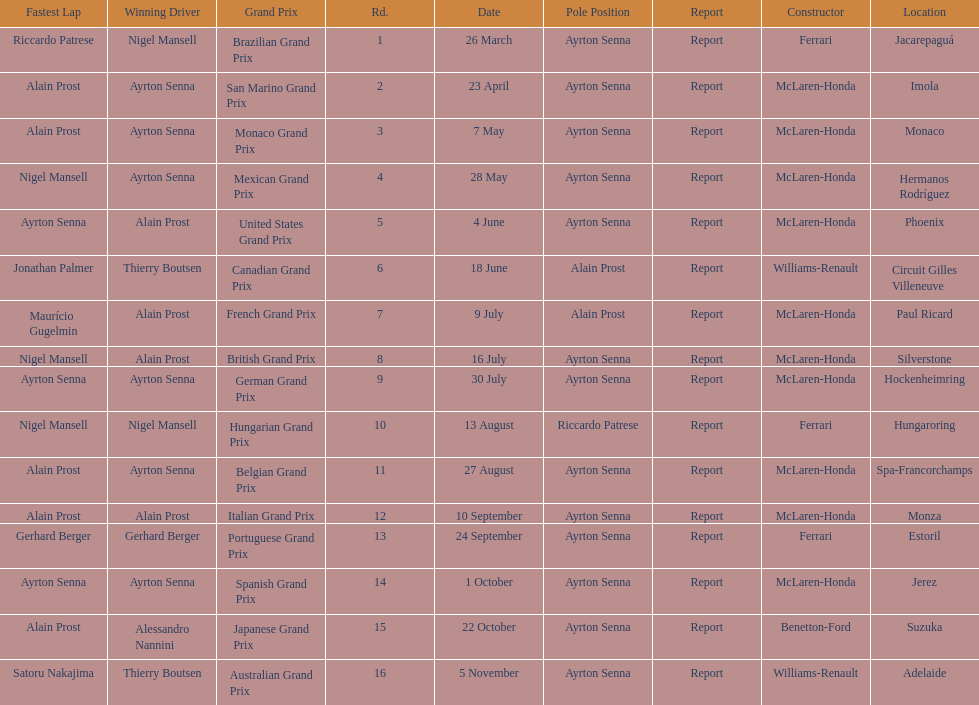Prost won the drivers title, who was his teammate? Ayrton Senna. Can you give me this table as a dict? {'header': ['Fastest Lap', 'Winning Driver', 'Grand Prix', 'Rd.', 'Date', 'Pole Position', 'Report', 'Constructor', 'Location'], 'rows': [['Riccardo Patrese', 'Nigel Mansell', 'Brazilian Grand Prix', '1', '26 March', 'Ayrton Senna', 'Report', 'Ferrari', 'Jacarepaguá'], ['Alain Prost', 'Ayrton Senna', 'San Marino Grand Prix', '2', '23 April', 'Ayrton Senna', 'Report', 'McLaren-Honda', 'Imola'], ['Alain Prost', 'Ayrton Senna', 'Monaco Grand Prix', '3', '7 May', 'Ayrton Senna', 'Report', 'McLaren-Honda', 'Monaco'], ['Nigel Mansell', 'Ayrton Senna', 'Mexican Grand Prix', '4', '28 May', 'Ayrton Senna', 'Report', 'McLaren-Honda', 'Hermanos Rodríguez'], ['Ayrton Senna', 'Alain Prost', 'United States Grand Prix', '5', '4 June', 'Ayrton Senna', 'Report', 'McLaren-Honda', 'Phoenix'], ['Jonathan Palmer', 'Thierry Boutsen', 'Canadian Grand Prix', '6', '18 June', 'Alain Prost', 'Report', 'Williams-Renault', 'Circuit Gilles Villeneuve'], ['Maurício Gugelmin', 'Alain Prost', 'French Grand Prix', '7', '9 July', 'Alain Prost', 'Report', 'McLaren-Honda', 'Paul Ricard'], ['Nigel Mansell', 'Alain Prost', 'British Grand Prix', '8', '16 July', 'Ayrton Senna', 'Report', 'McLaren-Honda', 'Silverstone'], ['Ayrton Senna', 'Ayrton Senna', 'German Grand Prix', '9', '30 July', 'Ayrton Senna', 'Report', 'McLaren-Honda', 'Hockenheimring'], ['Nigel Mansell', 'Nigel Mansell', 'Hungarian Grand Prix', '10', '13 August', 'Riccardo Patrese', 'Report', 'Ferrari', 'Hungaroring'], ['Alain Prost', 'Ayrton Senna', 'Belgian Grand Prix', '11', '27 August', 'Ayrton Senna', 'Report', 'McLaren-Honda', 'Spa-Francorchamps'], ['Alain Prost', 'Alain Prost', 'Italian Grand Prix', '12', '10 September', 'Ayrton Senna', 'Report', 'McLaren-Honda', 'Monza'], ['Gerhard Berger', 'Gerhard Berger', 'Portuguese Grand Prix', '13', '24 September', 'Ayrton Senna', 'Report', 'Ferrari', 'Estoril'], ['Ayrton Senna', 'Ayrton Senna', 'Spanish Grand Prix', '14', '1 October', 'Ayrton Senna', 'Report', 'McLaren-Honda', 'Jerez'], ['Alain Prost', 'Alessandro Nannini', 'Japanese Grand Prix', '15', '22 October', 'Ayrton Senna', 'Report', 'Benetton-Ford', 'Suzuka'], ['Satoru Nakajima', 'Thierry Boutsen', 'Australian Grand Prix', '16', '5 November', 'Ayrton Senna', 'Report', 'Williams-Renault', 'Adelaide']]} 